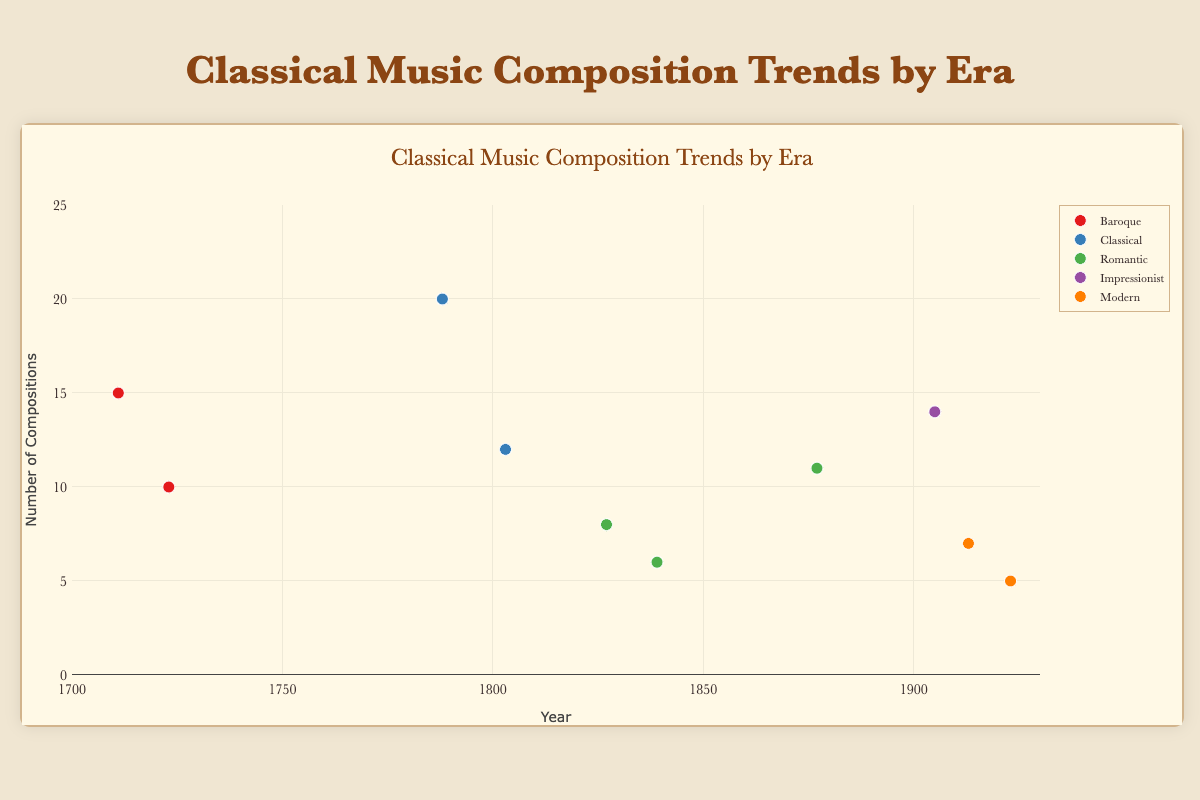What's the title of the figure? The title is prominently displayed at the top center of the figure. It reads "Classical Music Composition Trends by Era".
Answer: Classical Music Composition Trends by Era What are the x-axis and y-axis titles? The x-axis title is "Year" and the y-axis title is "Number of Compositions". These titles are clearly labeled along the horizontal and vertical axes, respectively.
Answer: Year; Number of Compositions Which era has the highest number of compositions for a single composer and who is the composer? The composer with the highest number of compositions in a single era is Wolfgang Amadeus Mozart from the Classical era with 20 compositions. You can see a point in the Classical group that peaks at the top of the y-axis, reaching 20 compositions.
Answer: Classical; Wolfgang Amadeus Mozart How many compositions did Johann Sebastian Bach and Antonio Vivaldi collectively compose? Johann Sebastian Bach composed 10 compositions and Antonio Vivaldi composed 15 compositions. Adding these together gives us 10 + 15 = 25 compositions.
Answer: 25 In which era and year do we see compositions related to "Industrial Revolution spreading across Europe"? Franz Schubert, in the Romantic Era, in the year 1827, has compositions connected with the societal change of the "Industrial Revolution spreading across Europe", as indicated in the text associated with the scatter plot point.
Answer: Romantic; 1827 Which era has the least number of total compositions among the represented composers? By summing up the compositions in each era: Baroque (10 + 15 = 25), Classical (12 + 20 = 32), Romantic (8 + 6 + 11 = 25), Impressionist (14), and Modern (7 + 5 = 12), we see that the Modern era has the least number of total compositions, totaling 12.
Answer: Modern Compare the number of compositions by Frédéric Chopin to that of Pyotr Ilyich Tchaikovsky. Which composer has more compositions and by how many? Frédéric Chopin has 6 compositions and Pyotr Ilyich Tchaikovsky has 11 compositions. Tchaikovsky has 11 - 6 = 5 more compositions than Chopin.
Answer: Pyotr Ilyich Tchaikovsky; 5 Which composer created compositions during the year 1905, and what was the associated societal change? In the year 1905, the composer Claude Debussy made compositions, with the associated societal change being "Modernism and shifts in artistic expression". This is indicated in the data point for the year 1905 within the Impressionist era.
Answer: Claude Debussy; Modernism and shifts in artistic expression Which era and societal changes are associated with Igor Stravinsky’s compositions? Igor Stravinsky is associated with the Modern era, and the societal changes during his time include "World War I and early 20th century turmoil". This is evident from the data point in the Modern era for the year 1913.
Answer: Modern; World War I and early 20th century turmoil 